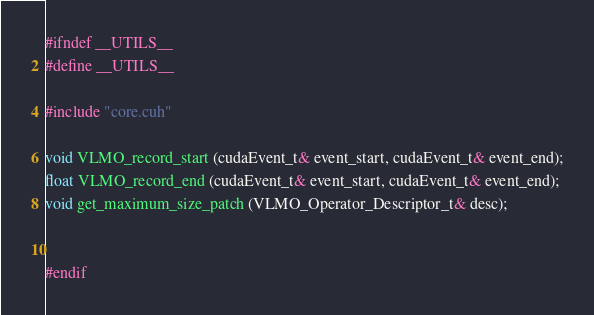<code> <loc_0><loc_0><loc_500><loc_500><_Cuda_>#ifndef __UTILS__
#define __UTILS__

#include "core.cuh"

void VLMO_record_start (cudaEvent_t& event_start, cudaEvent_t& event_end);
float VLMO_record_end (cudaEvent_t& event_start, cudaEvent_t& event_end);
void get_maximum_size_patch (VLMO_Operator_Descriptor_t& desc);


#endif
</code> 